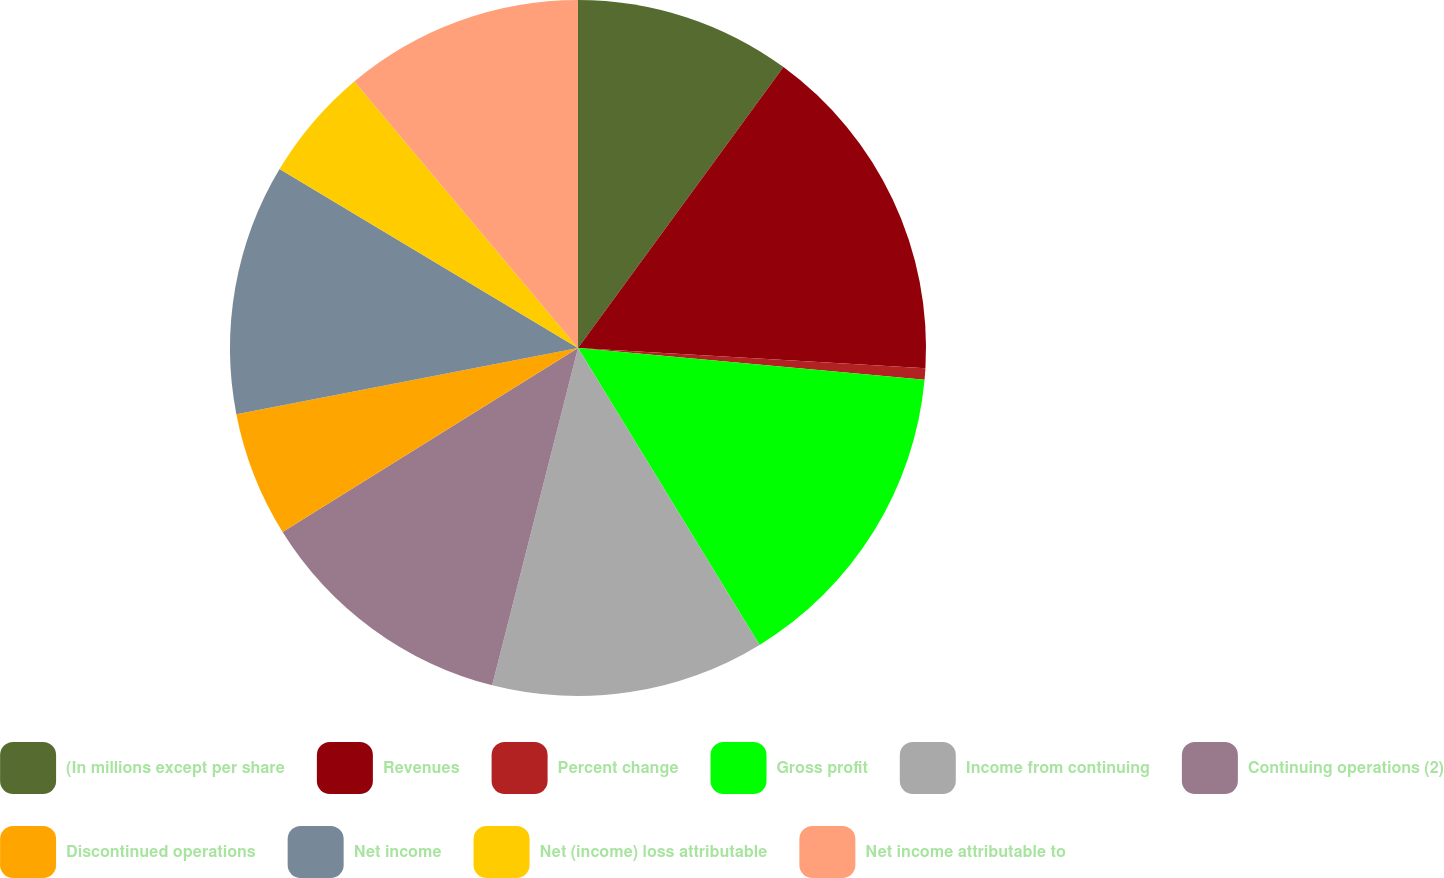<chart> <loc_0><loc_0><loc_500><loc_500><pie_chart><fcel>(In millions except per share<fcel>Revenues<fcel>Percent change<fcel>Gross profit<fcel>Income from continuing<fcel>Continuing operations (2)<fcel>Discontinued operations<fcel>Net income<fcel>Net (income) loss attributable<fcel>Net income attributable to<nl><fcel>10.05%<fcel>15.87%<fcel>0.53%<fcel>14.81%<fcel>12.7%<fcel>12.17%<fcel>5.82%<fcel>11.64%<fcel>5.29%<fcel>11.11%<nl></chart> 